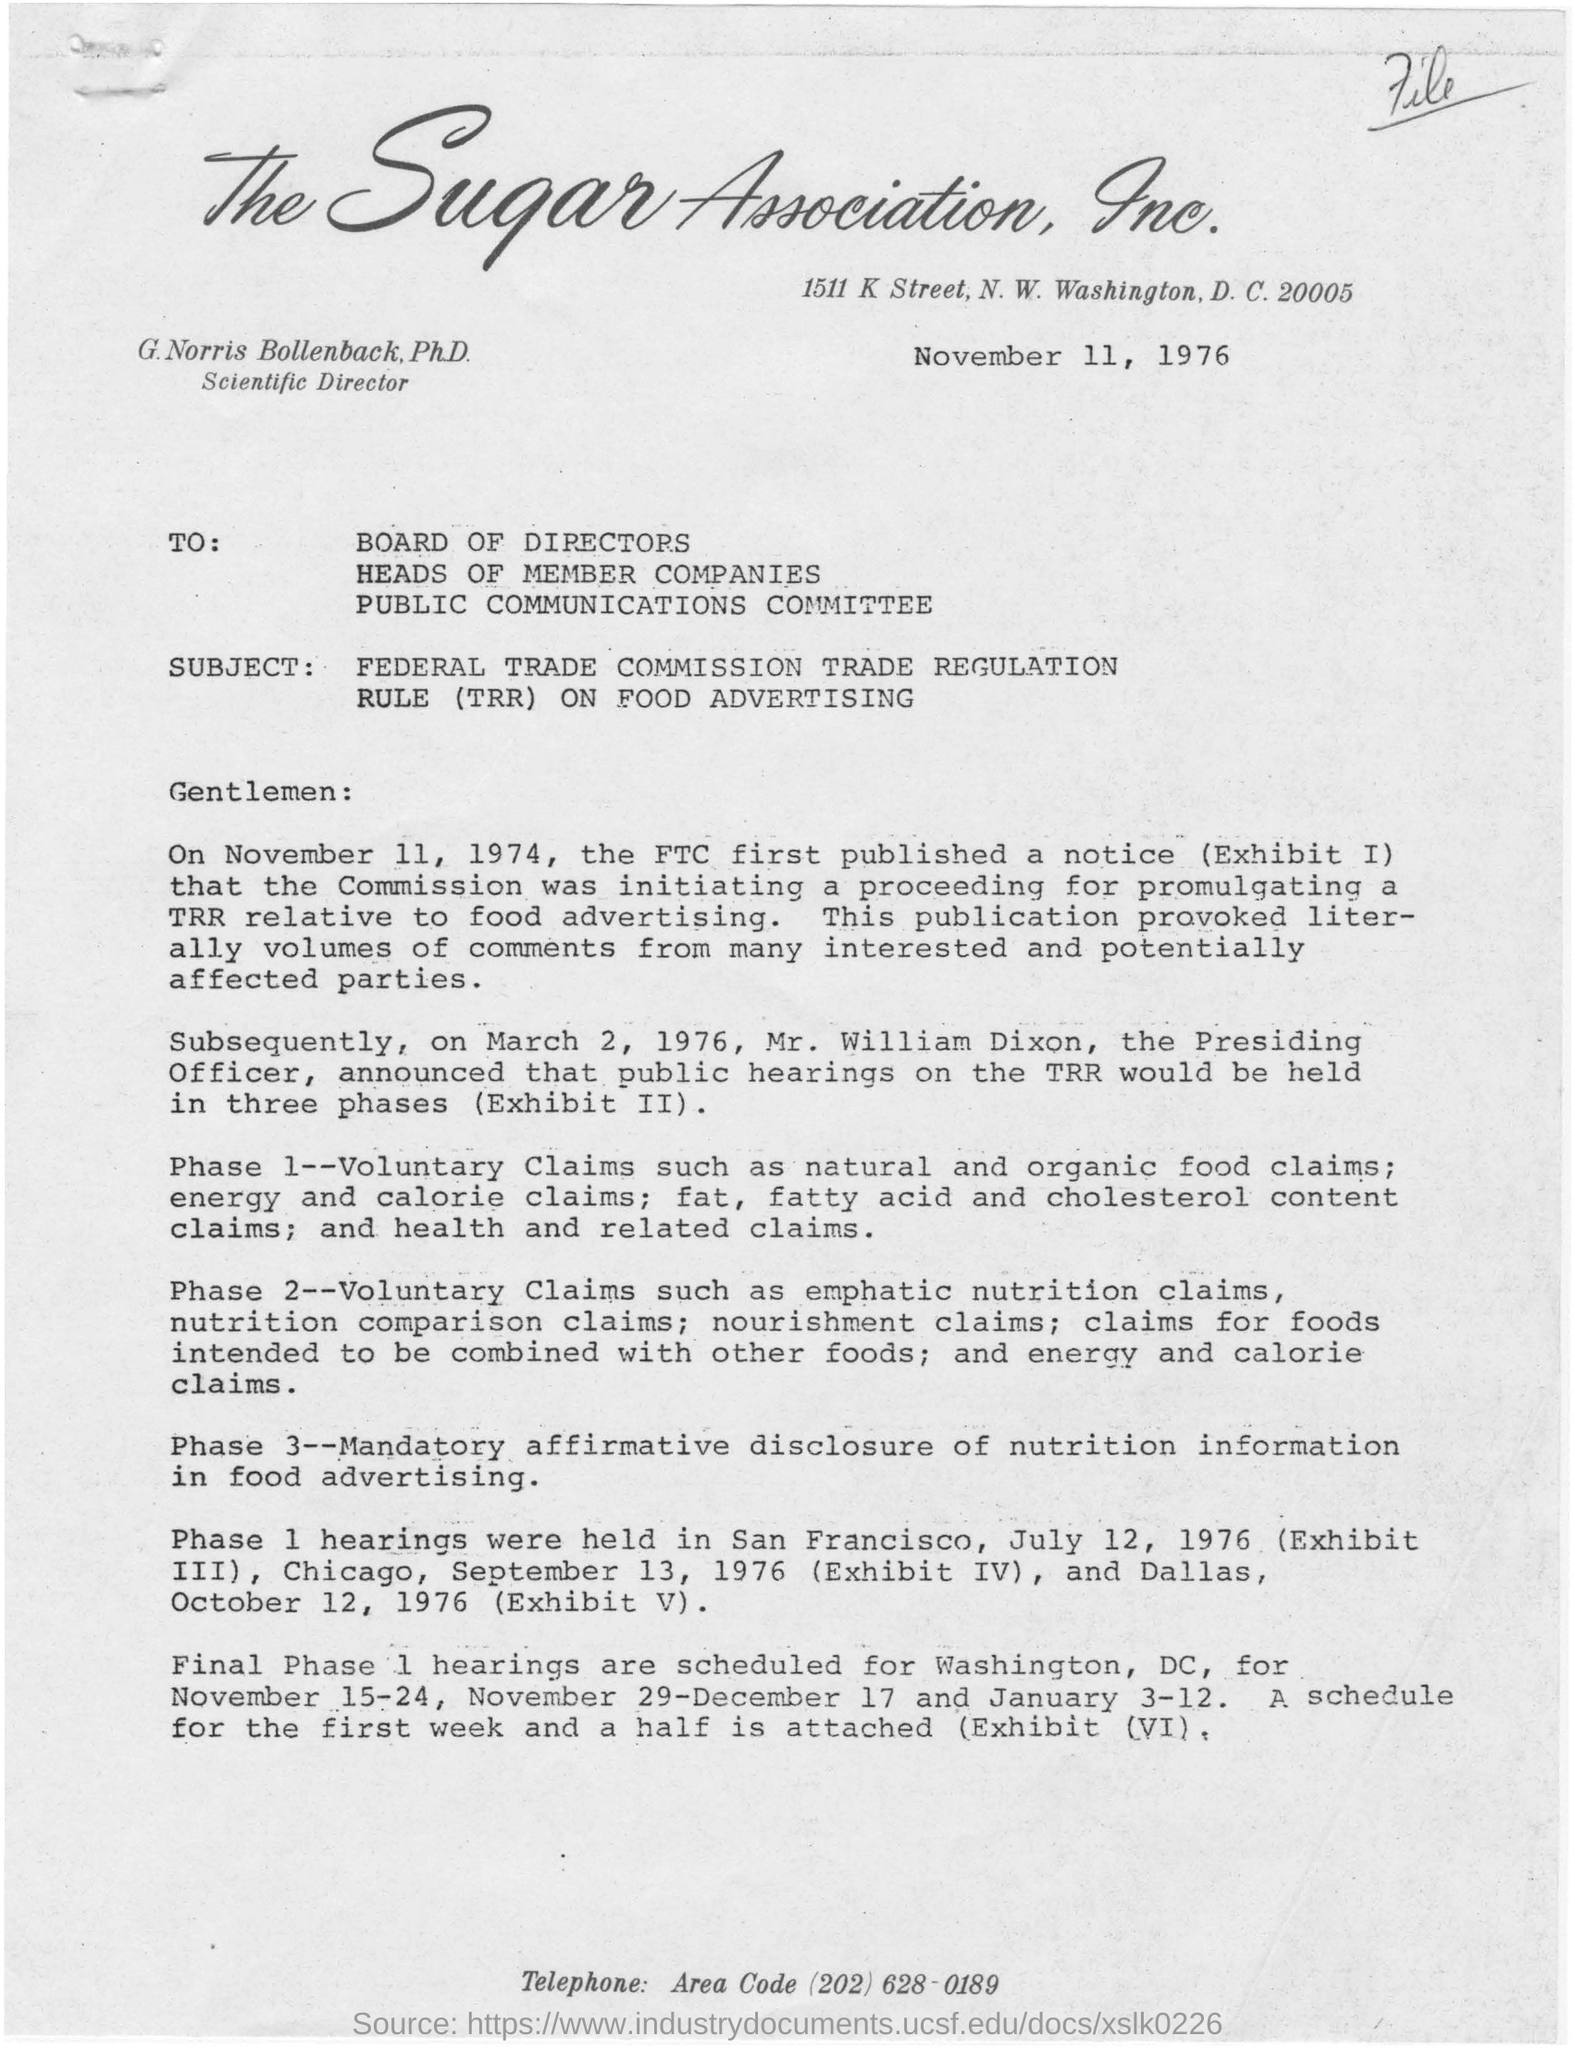Mention a couple of crucial points in this snapshot. The public hearings on the TRR will be held in three phases, as announced by Mr. William Dixon. The letter is dated on November 11, 1976. The Federal Trade Commission (FTC) first published a notice on November 11, 1974. 